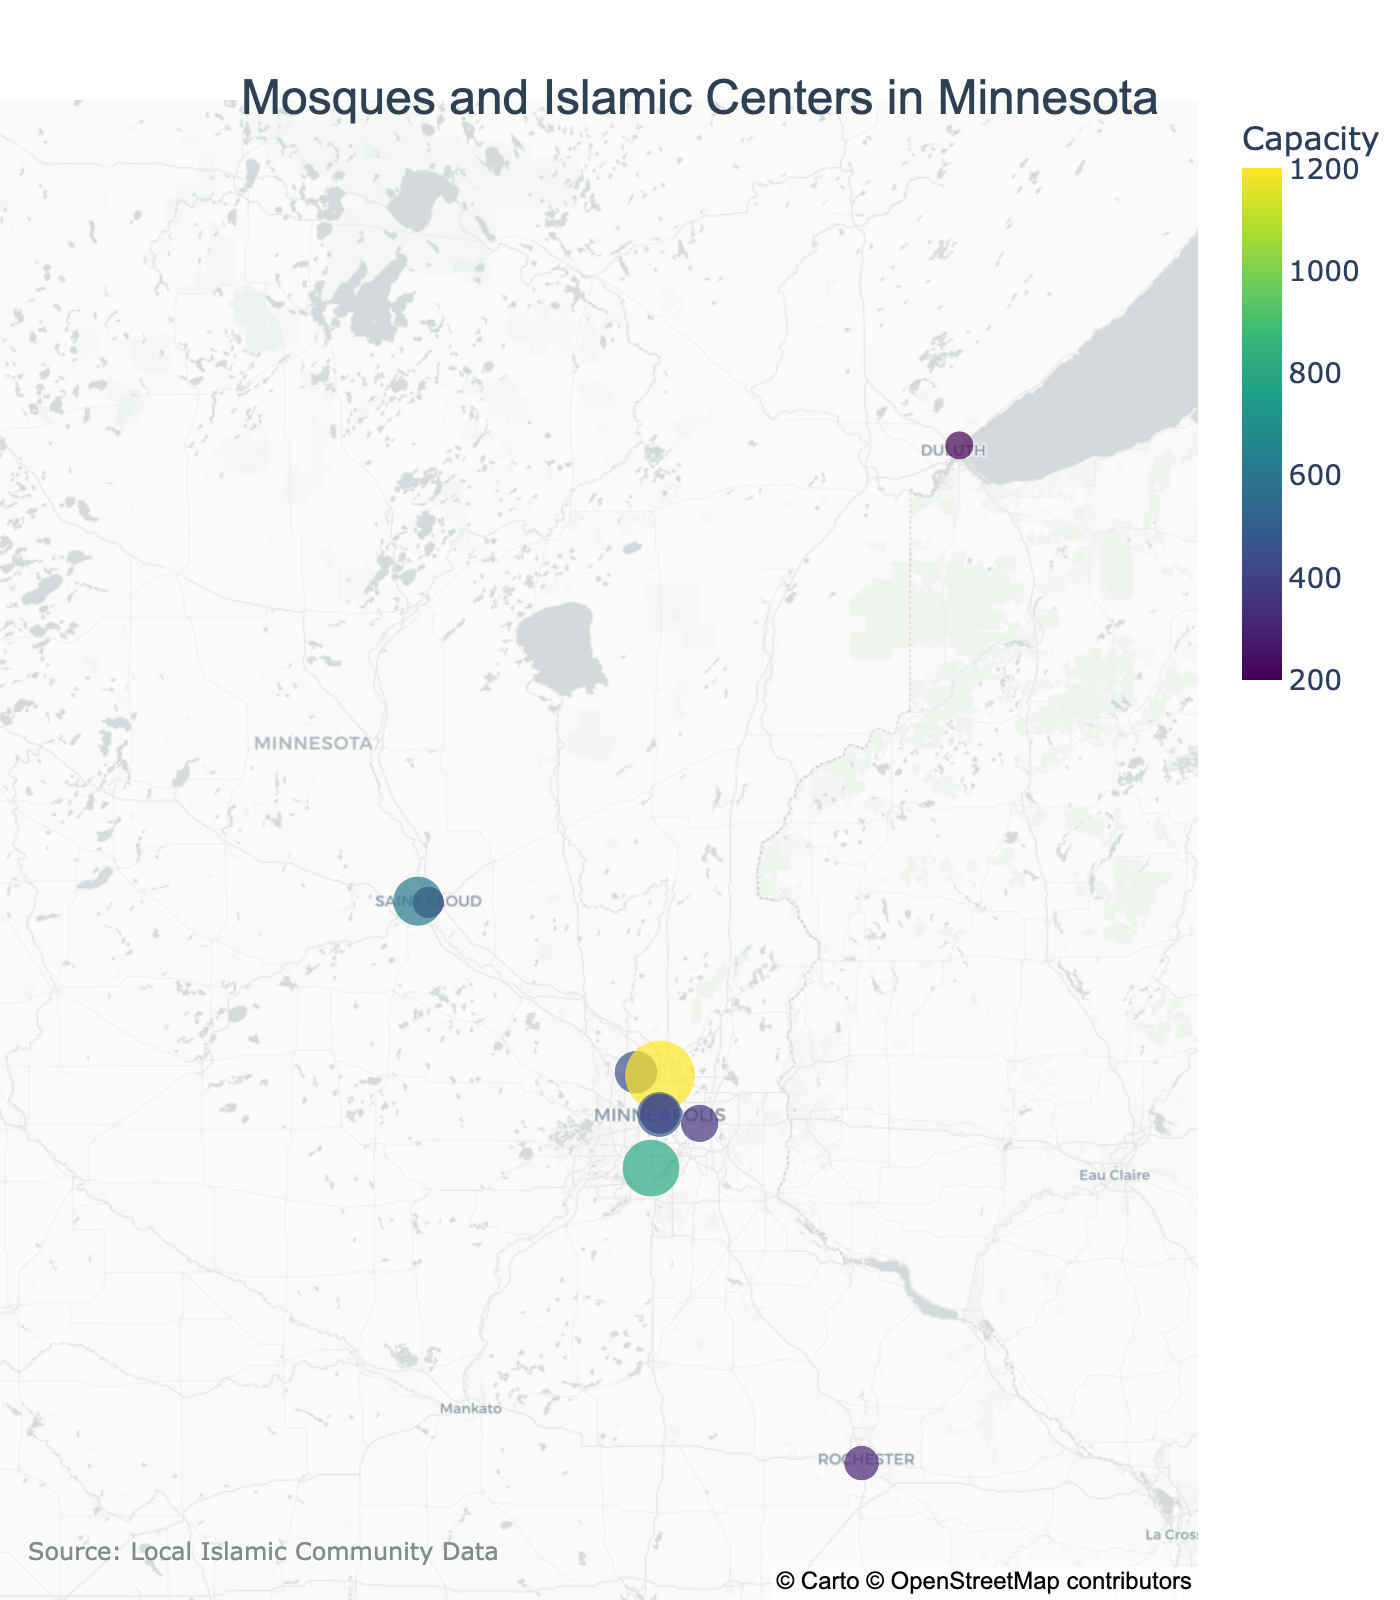What is the title of the plot? The title of the plot is usually placed at the top and it helps in understanding the primary focus of the plot.
Answer: Mosques and Islamic Centers in Minnesota Which mosque has the highest capacity? By observing the size and color of the dots on the map, the mosque with the largest dot representing capacity should be identified.
Answer: Islamic Center of Minnesota How many mosques are located in Minneapolis? The figure's hover data or visual identification at the specified geographic location (Minneapolis) can be used to count the number of mosques.
Answer: 2 Which city has the smallest mosque in terms of capacity? By looking for the smallest dot on the map and checking the hover data, the mosque with the smallest capacity can be found.
Answer: Duluth What is the color scale used to represent capacity in the plot? The color scale visually represents the capacity variations and is usually indicated in the legend/axis.
Answer: Viridis What is the approximate capacity range of the mosques shown on the plot? By observing the color legend and the dot sizes, one can identify the lowest and highest capacity values.
Answer: 200 to 1200 How is the map visually centered and what is the zoom level? The map's center and zoom level are typically determined by the default view, which usually positions the data points visibly.
Answer: Center: (45.7, -93.5), Zoom: 6.5 Which of the mosques has a capacity closest to the median among the listed capacities? List the capacities, find their median, and determine the mosque closest in value using the visual dot representations. Use median calculation steps: Sort capacities (200, 250, 300, 350, 400, 450, 500, 600, 800, 1200), Middle value picking (450+400)/2 = 425, comparing to given values.
Answer: Masjid Al-Ansar (capacity 450) How many mosques are there in total on the map? Count the number of dots representing mosques on the geographic plot.
Answer: 10 What additional information is provided in the annotations of the plot? Plot annotations typically provide source or supplementary information placed aside or at the bottom.
Answer: Source: Local Islamic Community Data 